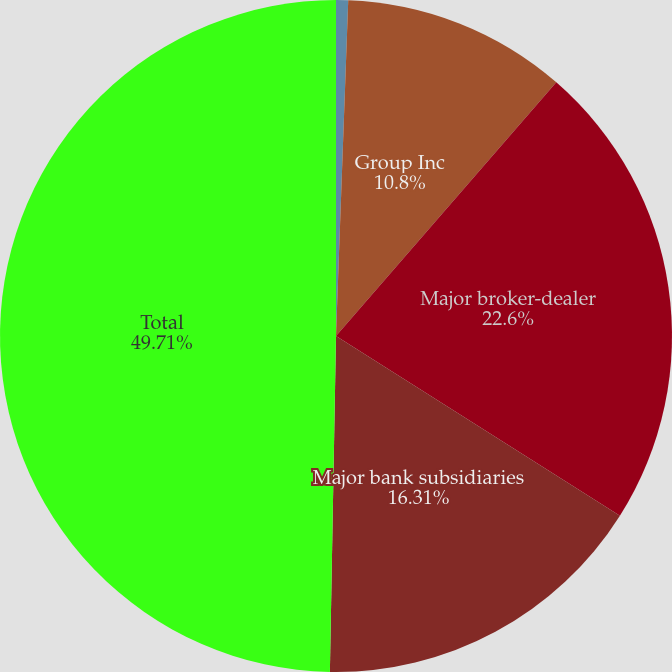Convert chart. <chart><loc_0><loc_0><loc_500><loc_500><pie_chart><fcel>in millions<fcel>Group Inc<fcel>Major broker-dealer<fcel>Major bank subsidiaries<fcel>Total<nl><fcel>0.58%<fcel>10.8%<fcel>22.6%<fcel>16.31%<fcel>49.71%<nl></chart> 